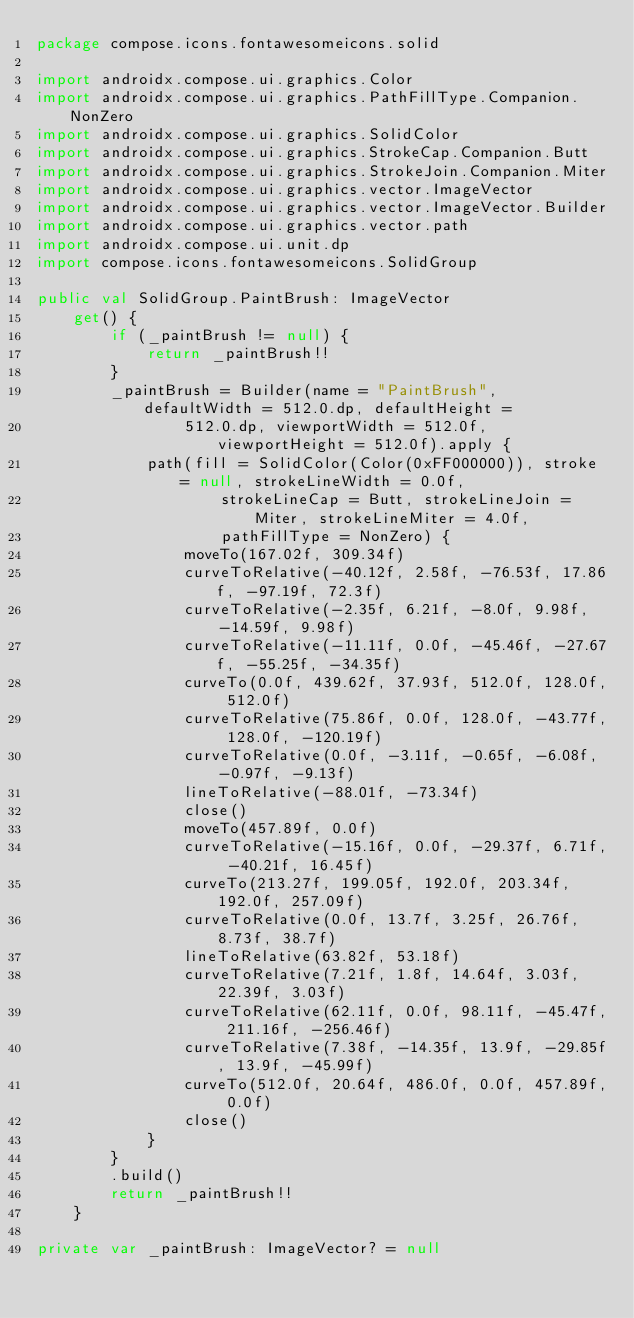<code> <loc_0><loc_0><loc_500><loc_500><_Kotlin_>package compose.icons.fontawesomeicons.solid

import androidx.compose.ui.graphics.Color
import androidx.compose.ui.graphics.PathFillType.Companion.NonZero
import androidx.compose.ui.graphics.SolidColor
import androidx.compose.ui.graphics.StrokeCap.Companion.Butt
import androidx.compose.ui.graphics.StrokeJoin.Companion.Miter
import androidx.compose.ui.graphics.vector.ImageVector
import androidx.compose.ui.graphics.vector.ImageVector.Builder
import androidx.compose.ui.graphics.vector.path
import androidx.compose.ui.unit.dp
import compose.icons.fontawesomeicons.SolidGroup

public val SolidGroup.PaintBrush: ImageVector
    get() {
        if (_paintBrush != null) {
            return _paintBrush!!
        }
        _paintBrush = Builder(name = "PaintBrush", defaultWidth = 512.0.dp, defaultHeight =
                512.0.dp, viewportWidth = 512.0f, viewportHeight = 512.0f).apply {
            path(fill = SolidColor(Color(0xFF000000)), stroke = null, strokeLineWidth = 0.0f,
                    strokeLineCap = Butt, strokeLineJoin = Miter, strokeLineMiter = 4.0f,
                    pathFillType = NonZero) {
                moveTo(167.02f, 309.34f)
                curveToRelative(-40.12f, 2.58f, -76.53f, 17.86f, -97.19f, 72.3f)
                curveToRelative(-2.35f, 6.21f, -8.0f, 9.98f, -14.59f, 9.98f)
                curveToRelative(-11.11f, 0.0f, -45.46f, -27.67f, -55.25f, -34.35f)
                curveTo(0.0f, 439.62f, 37.93f, 512.0f, 128.0f, 512.0f)
                curveToRelative(75.86f, 0.0f, 128.0f, -43.77f, 128.0f, -120.19f)
                curveToRelative(0.0f, -3.11f, -0.65f, -6.08f, -0.97f, -9.13f)
                lineToRelative(-88.01f, -73.34f)
                close()
                moveTo(457.89f, 0.0f)
                curveToRelative(-15.16f, 0.0f, -29.37f, 6.71f, -40.21f, 16.45f)
                curveTo(213.27f, 199.05f, 192.0f, 203.34f, 192.0f, 257.09f)
                curveToRelative(0.0f, 13.7f, 3.25f, 26.76f, 8.73f, 38.7f)
                lineToRelative(63.82f, 53.18f)
                curveToRelative(7.21f, 1.8f, 14.64f, 3.03f, 22.39f, 3.03f)
                curveToRelative(62.11f, 0.0f, 98.11f, -45.47f, 211.16f, -256.46f)
                curveToRelative(7.38f, -14.35f, 13.9f, -29.85f, 13.9f, -45.99f)
                curveTo(512.0f, 20.64f, 486.0f, 0.0f, 457.89f, 0.0f)
                close()
            }
        }
        .build()
        return _paintBrush!!
    }

private var _paintBrush: ImageVector? = null
</code> 